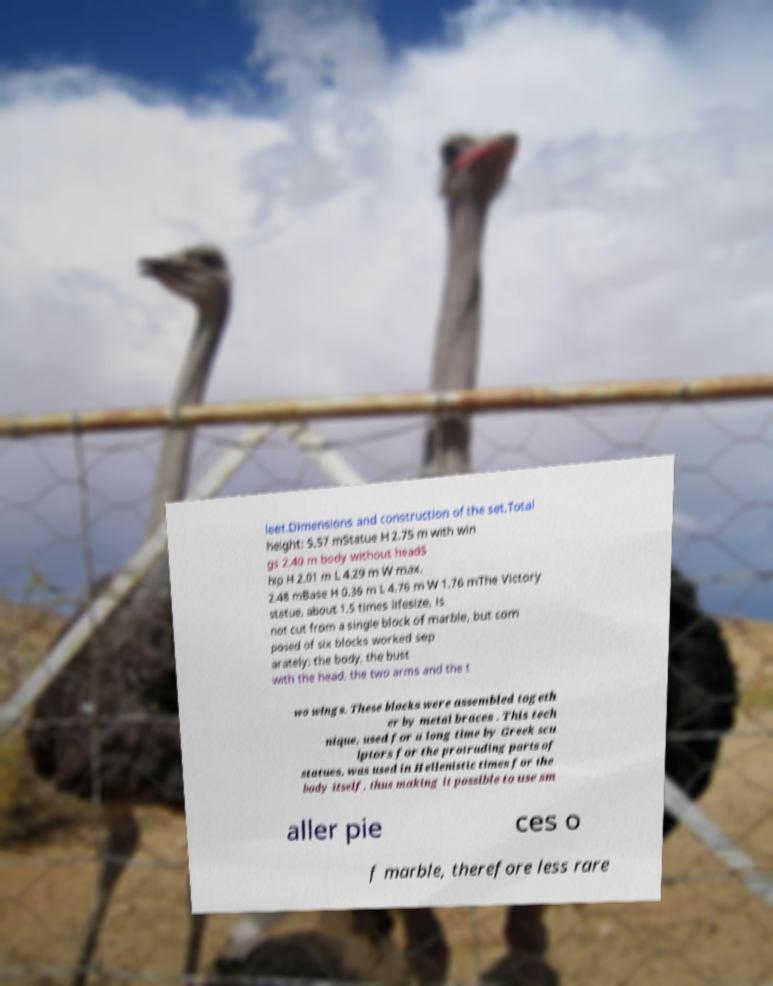Can you read and provide the text displayed in the image?This photo seems to have some interesting text. Can you extract and type it out for me? leet.Dimensions and construction of the set.Total height: 5.57 mStatue H 2.75 m with win gs 2.40 m body without headS hip H 2.01 m L 4.29 m W max. 2.48 mBase H 0.36 m L 4.76 m W 1.76 mThe Victory statue, about 1.5 times lifesize, is not cut from a single block of marble, but com posed of six blocks worked sep arately: the body, the bust with the head, the two arms and the t wo wings. These blocks were assembled togeth er by metal braces . This tech nique, used for a long time by Greek scu lptors for the protruding parts of statues, was used in Hellenistic times for the body itself, thus making it possible to use sm aller pie ces o f marble, therefore less rare 